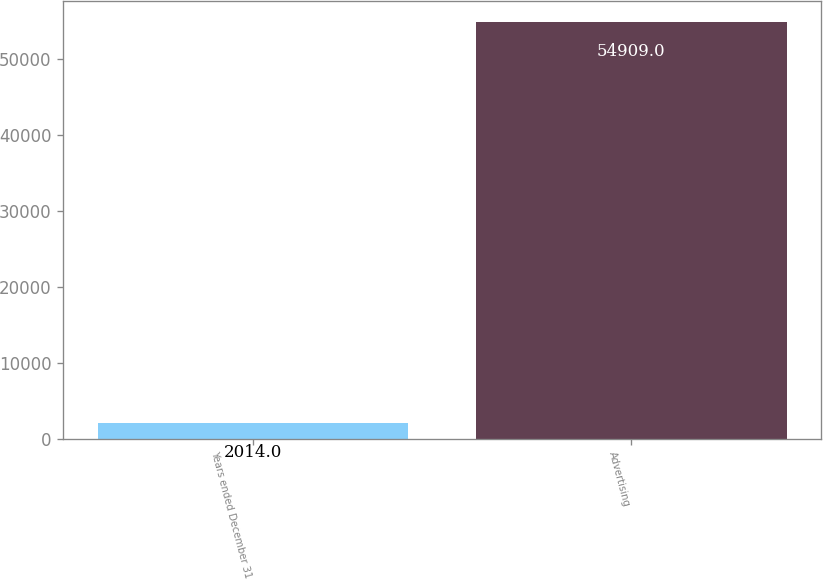<chart> <loc_0><loc_0><loc_500><loc_500><bar_chart><fcel>Years ended December 31<fcel>Advertising<nl><fcel>2014<fcel>54909<nl></chart> 